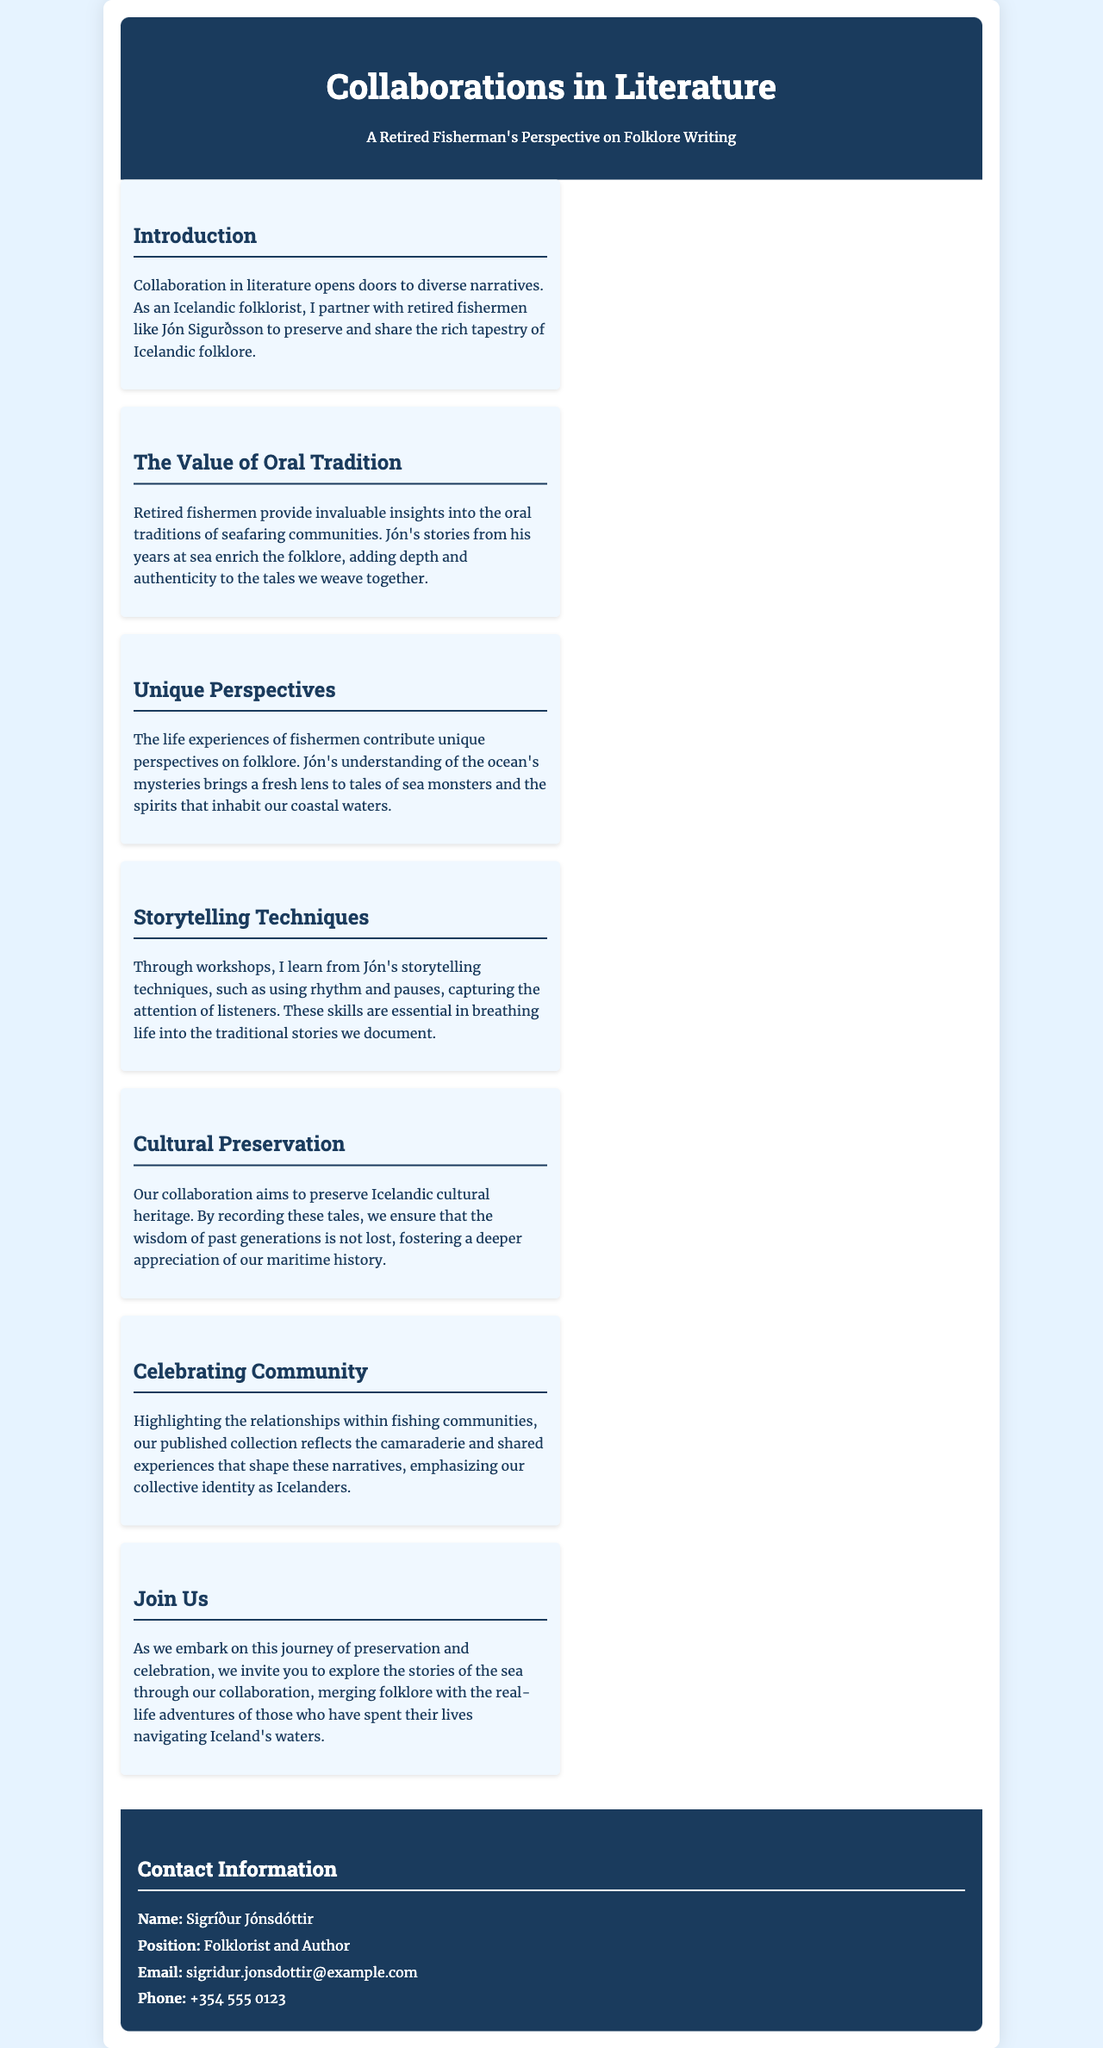What is the title of the brochure? The title appears prominently at the top of the document, indicating the subject of the brochure.
Answer: Collaborations in Literature: A Retired Fisherman's Perspective on Folklore Writing Who is the retired fisherman mentioned in the brochure? The brochure specifically names a retired fisherman who collaborates with the folklorist.
Answer: Jón Sigurðsson What role does Sigríður Jónsdóttir have? The position of the author is stated in the contact information section.
Answer: Folklorist and Author What is the main goal of the collaboration? The purpose of the partnership is explained in the cultural preservation section.
Answer: Preserve Icelandic cultural heritage What storytelling techniques does the folklorist learn from Jón? The techniques learned are detailed in the respective section that discusses storytelling methods.
Answer: Rhythm and pauses How does the collaboration contribute to community identity? This aspect is addressed in the section highlighting community relationships.
Answer: Emphasizing collective identity What is the email address provided for contact? The email address is found in the contact information section of the brochure.
Answer: sigridur.jonsdottir@example.com How does the collaboration enrich folklore? The document discusses how fishermen's stories add depth to folklore narratives.
Answer: Adds depth and authenticity What type of traditions do retired fishermen provide insights into? The specific traditions are mentioned in the oral tradition section.
Answer: Oral traditions of seafaring communities 